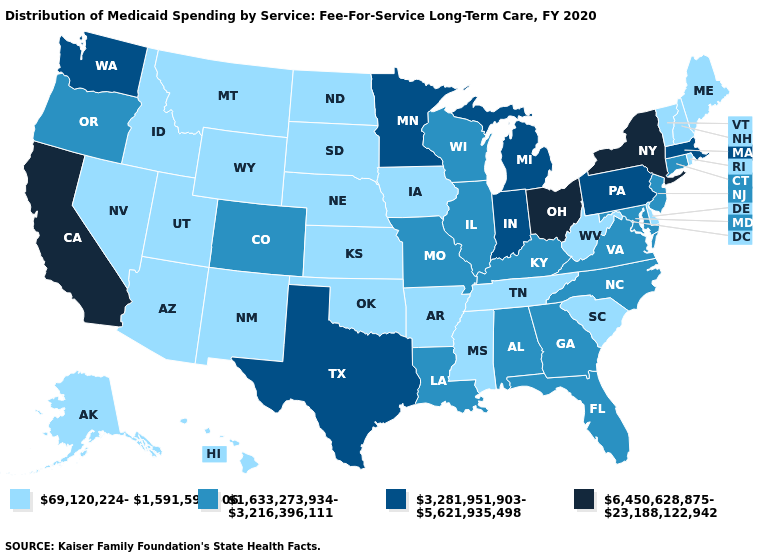Does the map have missing data?
Concise answer only. No. Does the first symbol in the legend represent the smallest category?
Short answer required. Yes. What is the lowest value in the USA?
Short answer required. 69,120,224-1,591,591,606. What is the value of New Jersey?
Be succinct. 1,633,273,934-3,216,396,111. Name the states that have a value in the range 1,633,273,934-3,216,396,111?
Quick response, please. Alabama, Colorado, Connecticut, Florida, Georgia, Illinois, Kentucky, Louisiana, Maryland, Missouri, New Jersey, North Carolina, Oregon, Virginia, Wisconsin. Does Wisconsin have the lowest value in the MidWest?
Be succinct. No. Among the states that border Iowa , which have the lowest value?
Quick response, please. Nebraska, South Dakota. Does Mississippi have the lowest value in the USA?
Concise answer only. Yes. What is the value of Michigan?
Be succinct. 3,281,951,903-5,621,935,498. What is the value of Arkansas?
Short answer required. 69,120,224-1,591,591,606. What is the value of Indiana?
Quick response, please. 3,281,951,903-5,621,935,498. What is the value of Florida?
Give a very brief answer. 1,633,273,934-3,216,396,111. Which states hav the highest value in the West?
Concise answer only. California. Name the states that have a value in the range 6,450,628,875-23,188,122,942?
Write a very short answer. California, New York, Ohio. Does Massachusetts have the lowest value in the USA?
Answer briefly. No. 